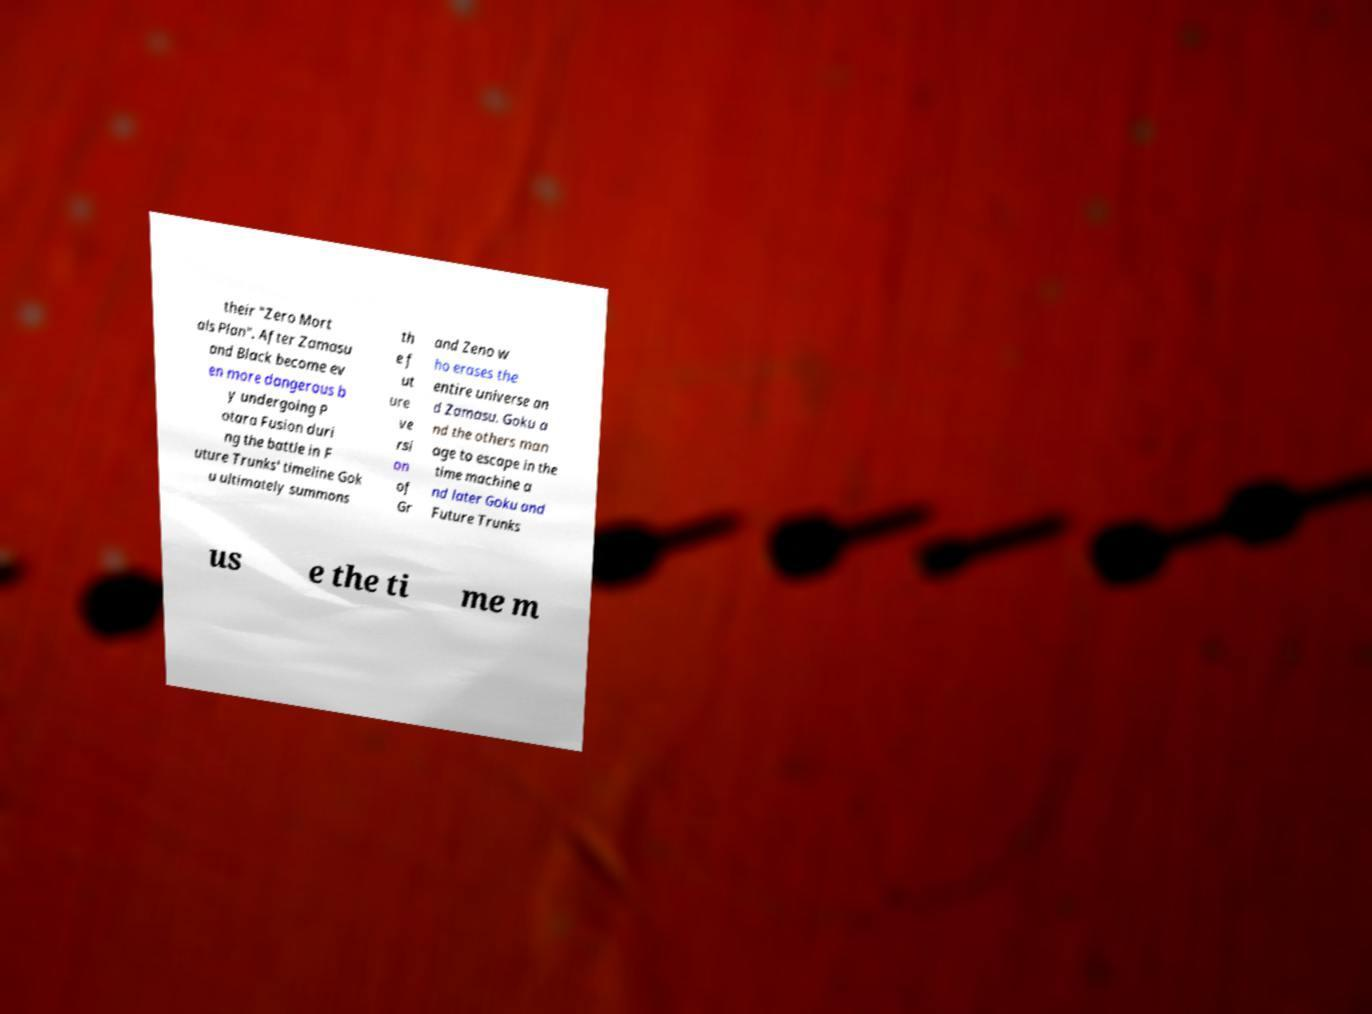Could you extract and type out the text from this image? their "Zero Mort als Plan". After Zamasu and Black become ev en more dangerous b y undergoing P otara Fusion duri ng the battle in F uture Trunks' timeline Gok u ultimately summons th e f ut ure ve rsi on of Gr and Zeno w ho erases the entire universe an d Zamasu. Goku a nd the others man age to escape in the time machine a nd later Goku and Future Trunks us e the ti me m 